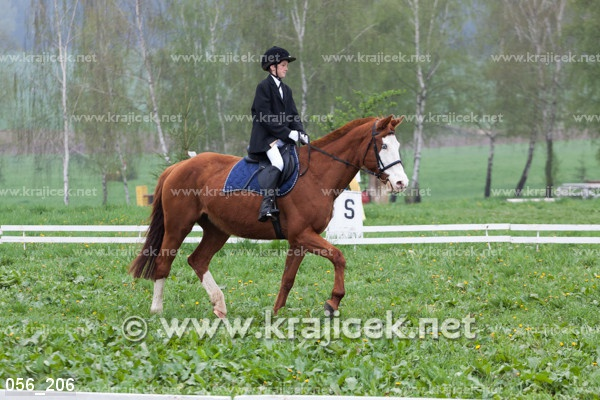Describe the objects in this image and their specific colors. I can see horse in darkgray, maroon, black, and brown tones, people in darkgray, black, gray, and white tones, and tie in darkgray, lavender, black, and gray tones in this image. 